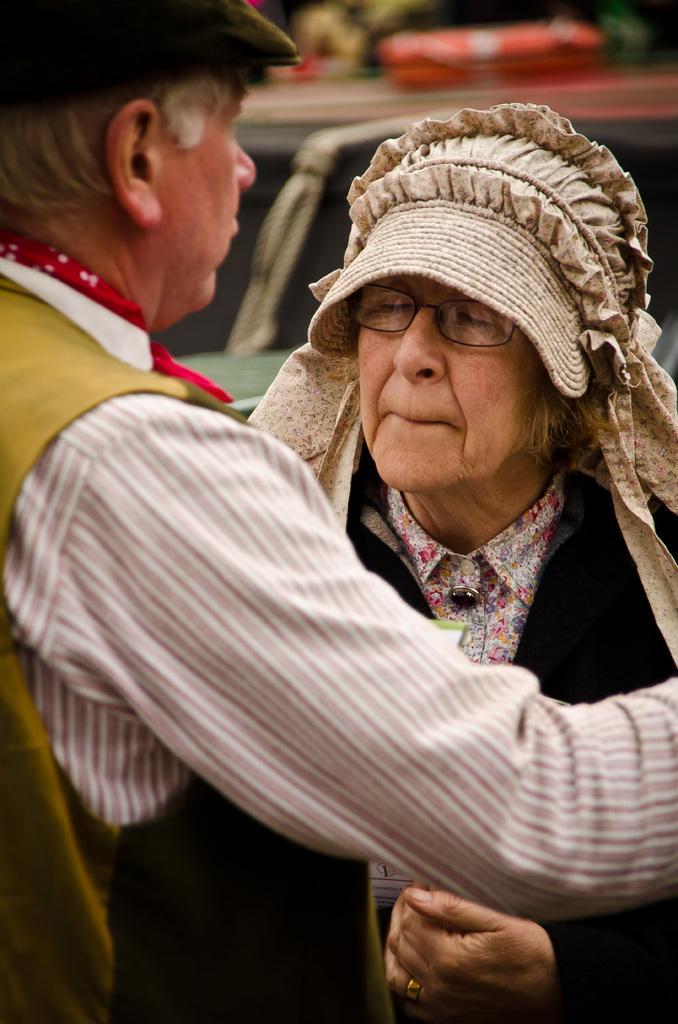Describe this image in one or two sentences. This image consists of two persons. On the left, we can see a person wearing a cap and a jacket. On the right, the woman is wearing a headgear. In the background, it looks like a vehicle. And the background is blurred. 